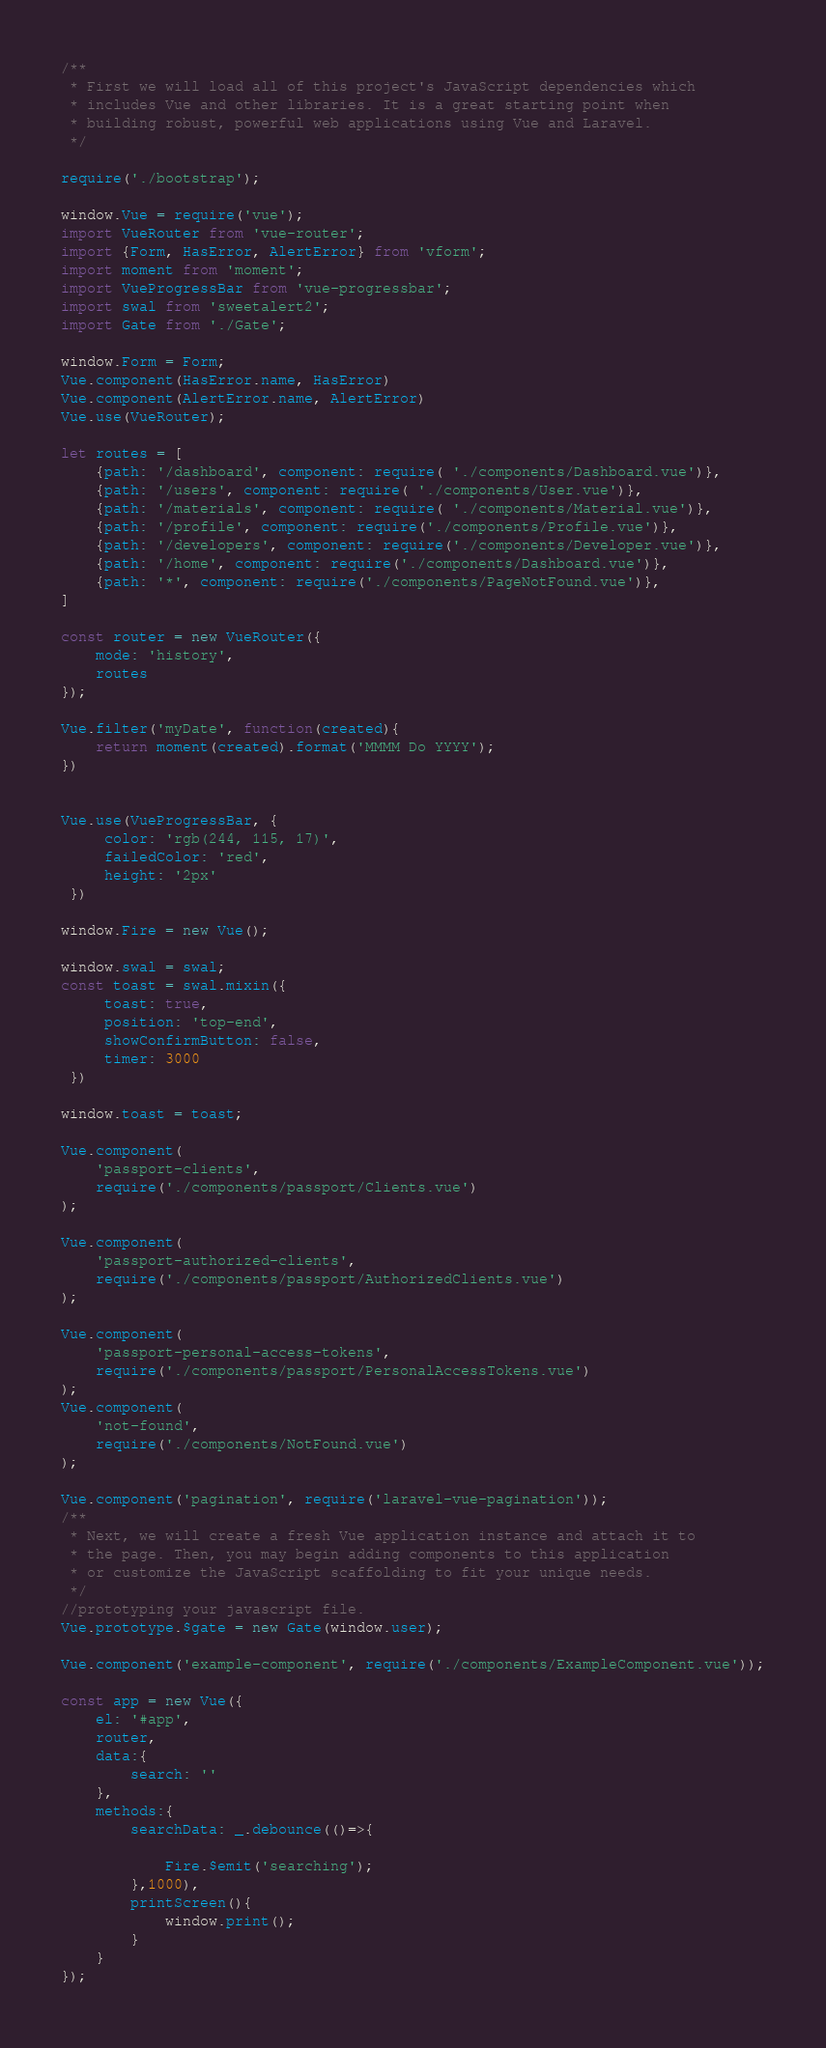Convert code to text. <code><loc_0><loc_0><loc_500><loc_500><_JavaScript_>
/**
 * First we will load all of this project's JavaScript dependencies which
 * includes Vue and other libraries. It is a great starting point when
 * building robust, powerful web applications using Vue and Laravel.
 */

require('./bootstrap');

window.Vue = require('vue');
import VueRouter from 'vue-router';
import {Form, HasError, AlertError} from 'vform';
import moment from 'moment';
import VueProgressBar from 'vue-progressbar';
import swal from 'sweetalert2';
import Gate from './Gate';

window.Form = Form;
Vue.component(HasError.name, HasError)
Vue.component(AlertError.name, AlertError)
Vue.use(VueRouter);

let routes = [
    {path: '/dashboard', component: require( './components/Dashboard.vue')},
    {path: '/users', component: require( './components/User.vue')},
    {path: '/materials', component: require( './components/Material.vue')},
    {path: '/profile', component: require('./components/Profile.vue')},
    {path: '/developers', component: require('./components/Developer.vue')},
    {path: '/home', component: require('./components/Dashboard.vue')},
    {path: '*', component: require('./components/PageNotFound.vue')},
]

const router = new VueRouter({
    mode: 'history',
    routes
});

Vue.filter('myDate', function(created){
    return moment(created).format('MMMM Do YYYY');
})


Vue.use(VueProgressBar, {
     color: 'rgb(244, 115, 17)',
     failedColor: 'red',
     height: '2px'
 })

window.Fire = new Vue();

window.swal = swal;
const toast = swal.mixin({
     toast: true,
     position: 'top-end',
     showConfirmButton: false,
     timer: 3000
 })

window.toast = toast;

Vue.component(
    'passport-clients',
    require('./components/passport/Clients.vue')
);

Vue.component(
    'passport-authorized-clients',
    require('./components/passport/AuthorizedClients.vue')
);

Vue.component(
    'passport-personal-access-tokens',
    require('./components/passport/PersonalAccessTokens.vue')
);
Vue.component(
    'not-found',
    require('./components/NotFound.vue')
);

Vue.component('pagination', require('laravel-vue-pagination'));
/**
 * Next, we will create a fresh Vue application instance and attach it to
 * the page. Then, you may begin adding components to this application
 * or customize the JavaScript scaffolding to fit your unique needs.
 */
//prototyping your javascript file.
Vue.prototype.$gate = new Gate(window.user);

Vue.component('example-component', require('./components/ExampleComponent.vue'));

const app = new Vue({
    el: '#app',
    router,
    data:{
        search: ''
    },
    methods:{
        searchData: _.debounce(()=>{
            
            Fire.$emit('searching');
        },1000),
        printScreen(){
            window.print();
        }
    }
});
</code> 